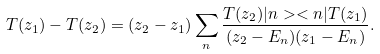Convert formula to latex. <formula><loc_0><loc_0><loc_500><loc_500>T ( z _ { 1 } ) - T ( z _ { 2 } ) = ( z _ { 2 } - z _ { 1 } ) \sum _ { n } \frac { T ( z _ { 2 } ) | n > < n | T ( z _ { 1 } ) } { ( z _ { 2 } - E _ { n } ) ( z _ { 1 } - E _ { n } ) } .</formula> 